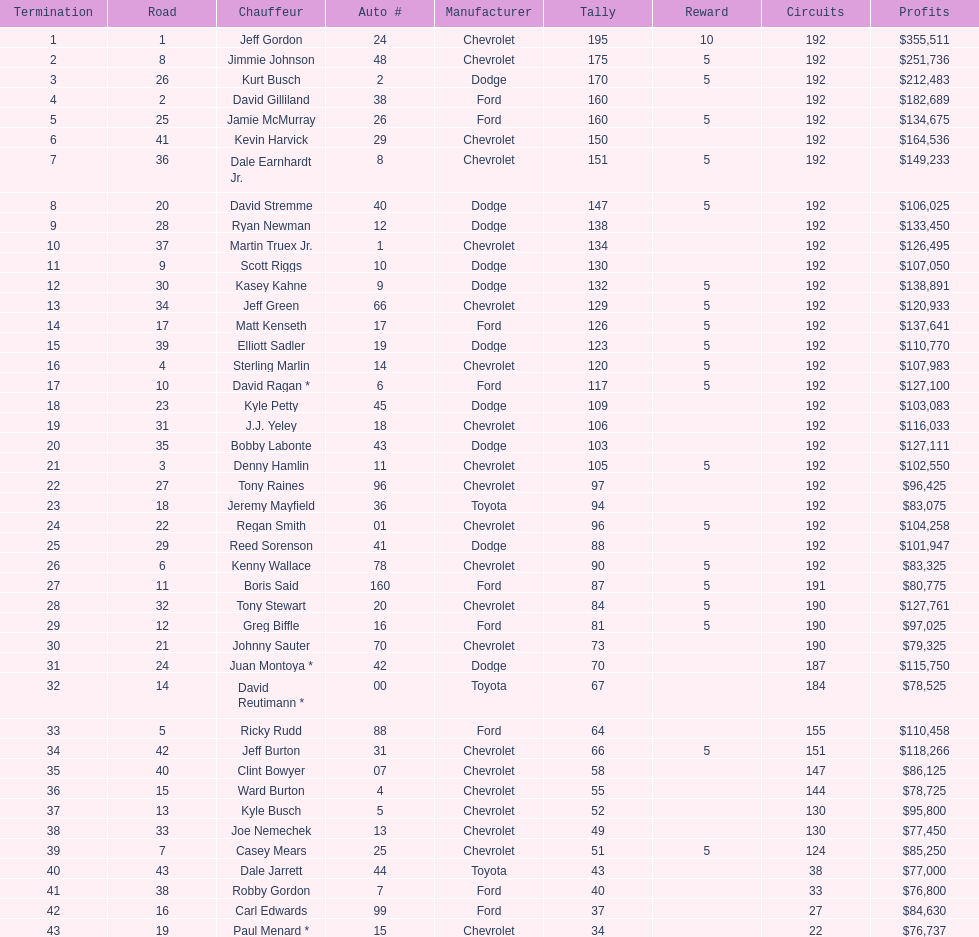What driver earned the least amount of winnings? Paul Menard *. Could you help me parse every detail presented in this table? {'header': ['Termination', 'Road', 'Chauffeur', 'Auto #', 'Manufacturer', 'Tally', 'Reward', 'Circuits', 'Profits'], 'rows': [['1', '1', 'Jeff Gordon', '24', 'Chevrolet', '195', '10', '192', '$355,511'], ['2', '8', 'Jimmie Johnson', '48', 'Chevrolet', '175', '5', '192', '$251,736'], ['3', '26', 'Kurt Busch', '2', 'Dodge', '170', '5', '192', '$212,483'], ['4', '2', 'David Gilliland', '38', 'Ford', '160', '', '192', '$182,689'], ['5', '25', 'Jamie McMurray', '26', 'Ford', '160', '5', '192', '$134,675'], ['6', '41', 'Kevin Harvick', '29', 'Chevrolet', '150', '', '192', '$164,536'], ['7', '36', 'Dale Earnhardt Jr.', '8', 'Chevrolet', '151', '5', '192', '$149,233'], ['8', '20', 'David Stremme', '40', 'Dodge', '147', '5', '192', '$106,025'], ['9', '28', 'Ryan Newman', '12', 'Dodge', '138', '', '192', '$133,450'], ['10', '37', 'Martin Truex Jr.', '1', 'Chevrolet', '134', '', '192', '$126,495'], ['11', '9', 'Scott Riggs', '10', 'Dodge', '130', '', '192', '$107,050'], ['12', '30', 'Kasey Kahne', '9', 'Dodge', '132', '5', '192', '$138,891'], ['13', '34', 'Jeff Green', '66', 'Chevrolet', '129', '5', '192', '$120,933'], ['14', '17', 'Matt Kenseth', '17', 'Ford', '126', '5', '192', '$137,641'], ['15', '39', 'Elliott Sadler', '19', 'Dodge', '123', '5', '192', '$110,770'], ['16', '4', 'Sterling Marlin', '14', 'Chevrolet', '120', '5', '192', '$107,983'], ['17', '10', 'David Ragan *', '6', 'Ford', '117', '5', '192', '$127,100'], ['18', '23', 'Kyle Petty', '45', 'Dodge', '109', '', '192', '$103,083'], ['19', '31', 'J.J. Yeley', '18', 'Chevrolet', '106', '', '192', '$116,033'], ['20', '35', 'Bobby Labonte', '43', 'Dodge', '103', '', '192', '$127,111'], ['21', '3', 'Denny Hamlin', '11', 'Chevrolet', '105', '5', '192', '$102,550'], ['22', '27', 'Tony Raines', '96', 'Chevrolet', '97', '', '192', '$96,425'], ['23', '18', 'Jeremy Mayfield', '36', 'Toyota', '94', '', '192', '$83,075'], ['24', '22', 'Regan Smith', '01', 'Chevrolet', '96', '5', '192', '$104,258'], ['25', '29', 'Reed Sorenson', '41', 'Dodge', '88', '', '192', '$101,947'], ['26', '6', 'Kenny Wallace', '78', 'Chevrolet', '90', '5', '192', '$83,325'], ['27', '11', 'Boris Said', '160', 'Ford', '87', '5', '191', '$80,775'], ['28', '32', 'Tony Stewart', '20', 'Chevrolet', '84', '5', '190', '$127,761'], ['29', '12', 'Greg Biffle', '16', 'Ford', '81', '5', '190', '$97,025'], ['30', '21', 'Johnny Sauter', '70', 'Chevrolet', '73', '', '190', '$79,325'], ['31', '24', 'Juan Montoya *', '42', 'Dodge', '70', '', '187', '$115,750'], ['32', '14', 'David Reutimann *', '00', 'Toyota', '67', '', '184', '$78,525'], ['33', '5', 'Ricky Rudd', '88', 'Ford', '64', '', '155', '$110,458'], ['34', '42', 'Jeff Burton', '31', 'Chevrolet', '66', '5', '151', '$118,266'], ['35', '40', 'Clint Bowyer', '07', 'Chevrolet', '58', '', '147', '$86,125'], ['36', '15', 'Ward Burton', '4', 'Chevrolet', '55', '', '144', '$78,725'], ['37', '13', 'Kyle Busch', '5', 'Chevrolet', '52', '', '130', '$95,800'], ['38', '33', 'Joe Nemechek', '13', 'Chevrolet', '49', '', '130', '$77,450'], ['39', '7', 'Casey Mears', '25', 'Chevrolet', '51', '5', '124', '$85,250'], ['40', '43', 'Dale Jarrett', '44', 'Toyota', '43', '', '38', '$77,000'], ['41', '38', 'Robby Gordon', '7', 'Ford', '40', '', '33', '$76,800'], ['42', '16', 'Carl Edwards', '99', 'Ford', '37', '', '27', '$84,630'], ['43', '19', 'Paul Menard *', '15', 'Chevrolet', '34', '', '22', '$76,737']]} 